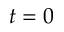<formula> <loc_0><loc_0><loc_500><loc_500>t = 0</formula> 